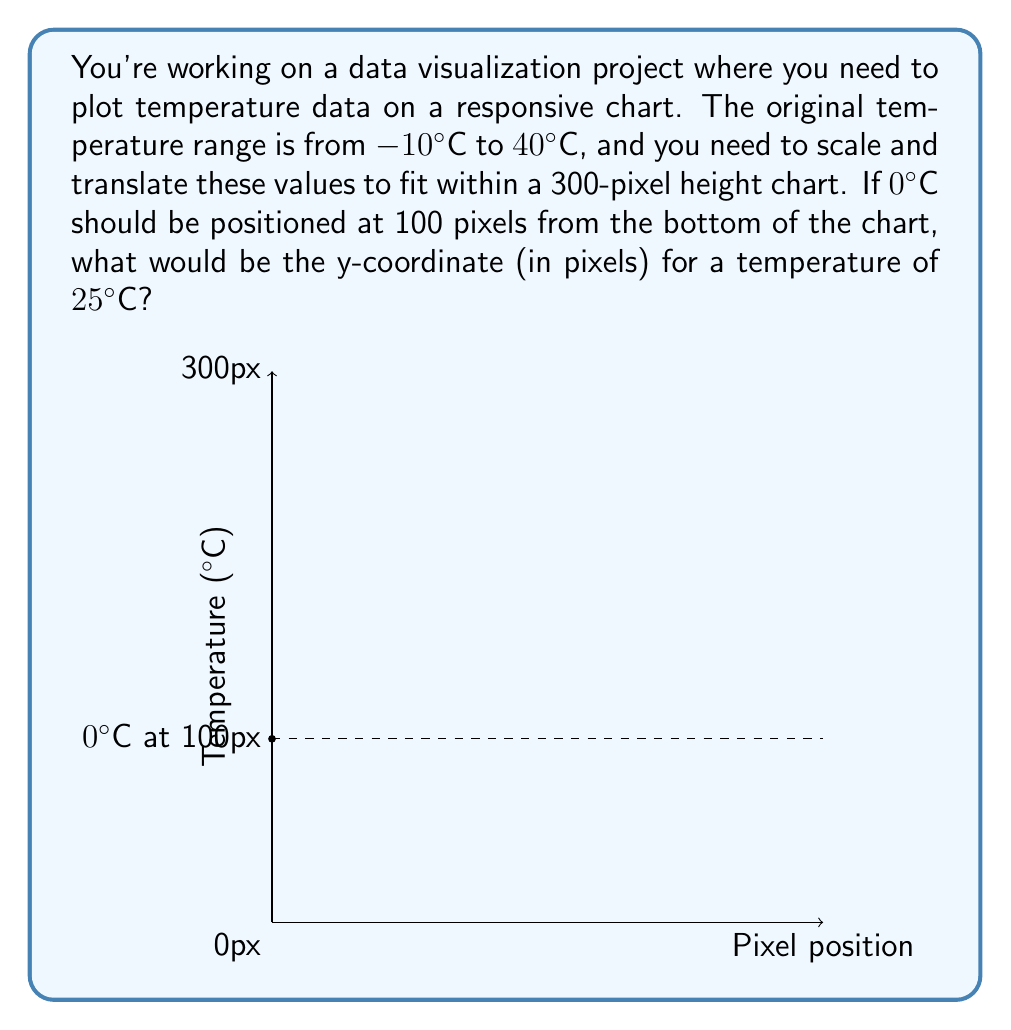Help me with this question. To solve this problem, we need to follow these steps:

1) First, let's determine the scale factor to map the temperature range to the pixel range:

   Temperature range: 40°C - (-10°C) = 50°C
   Pixel range: 300px - 0px = 300px

   Scale factor = $\frac{300\text{ px}}{50°\text{C}} = 6\text{ px/°C}$

2) Now, we need to create a linear function that maps temperature to pixel position:

   $f(T) = aT + b$, where $T$ is temperature, $a$ is our scale factor, and $b$ is the y-intercept

3) We know that 0°C should be at 100px, so we can use this to find $b$:

   $100 = a(0) + b$
   $b = 100$

4) Our function is now:

   $f(T) = 6T + 100$

5) To find the pixel position for 25°C, we simply plug it into our function:

   $f(25) = 6(25) + 100 = 150 + 100 = 250$

Therefore, a temperature of 25°C would be positioned at 250 pixels from the bottom of the chart.
Answer: 250 pixels 